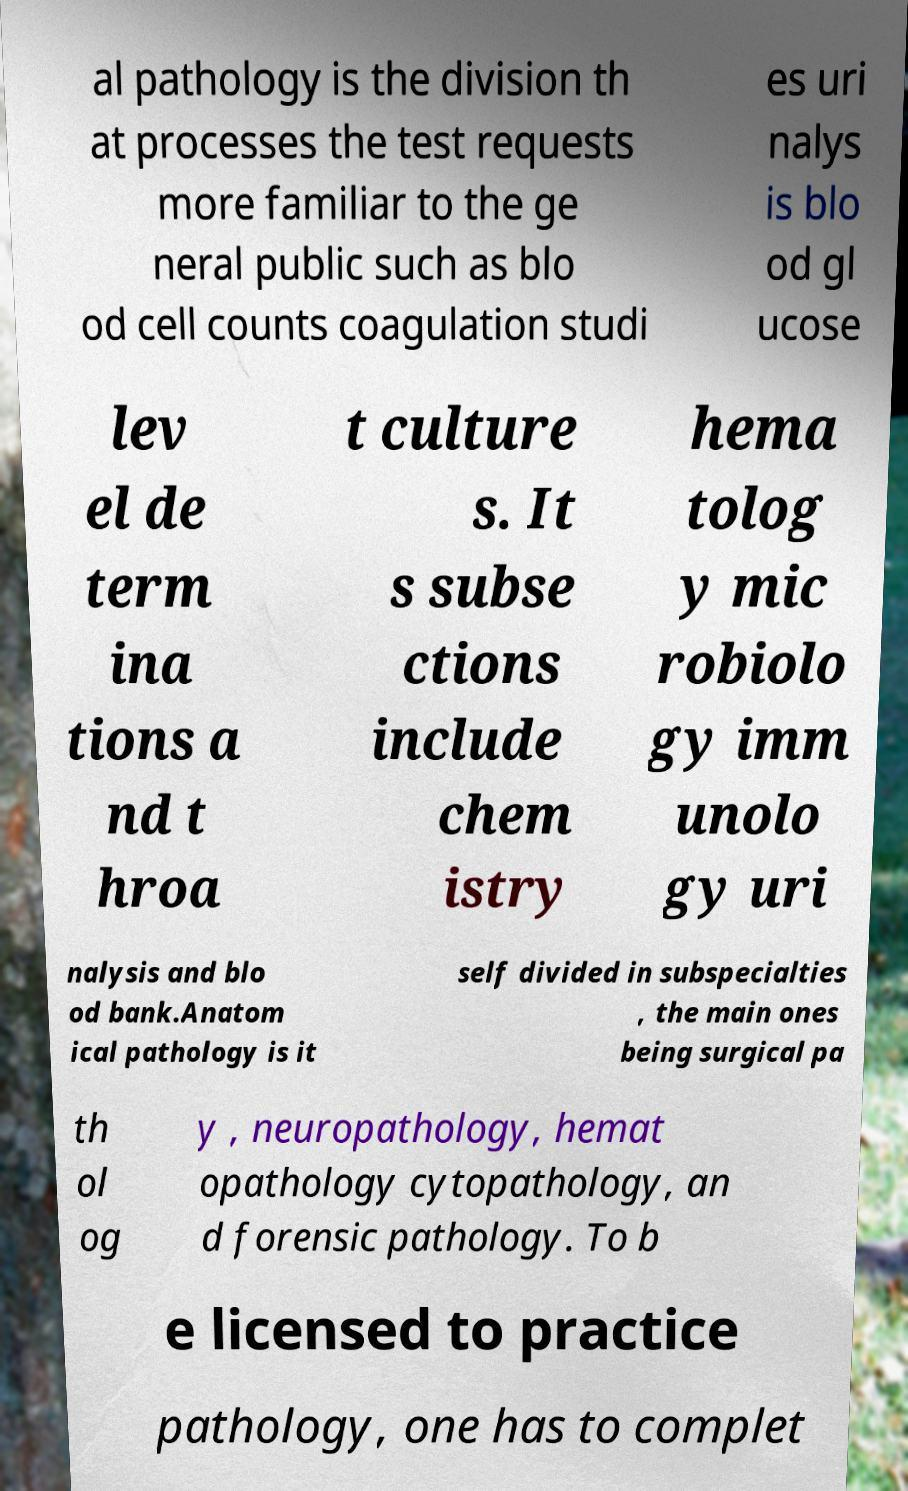Please identify and transcribe the text found in this image. al pathology is the division th at processes the test requests more familiar to the ge neral public such as blo od cell counts coagulation studi es uri nalys is blo od gl ucose lev el de term ina tions a nd t hroa t culture s. It s subse ctions include chem istry hema tolog y mic robiolo gy imm unolo gy uri nalysis and blo od bank.Anatom ical pathology is it self divided in subspecialties , the main ones being surgical pa th ol og y , neuropathology, hemat opathology cytopathology, an d forensic pathology. To b e licensed to practice pathology, one has to complet 